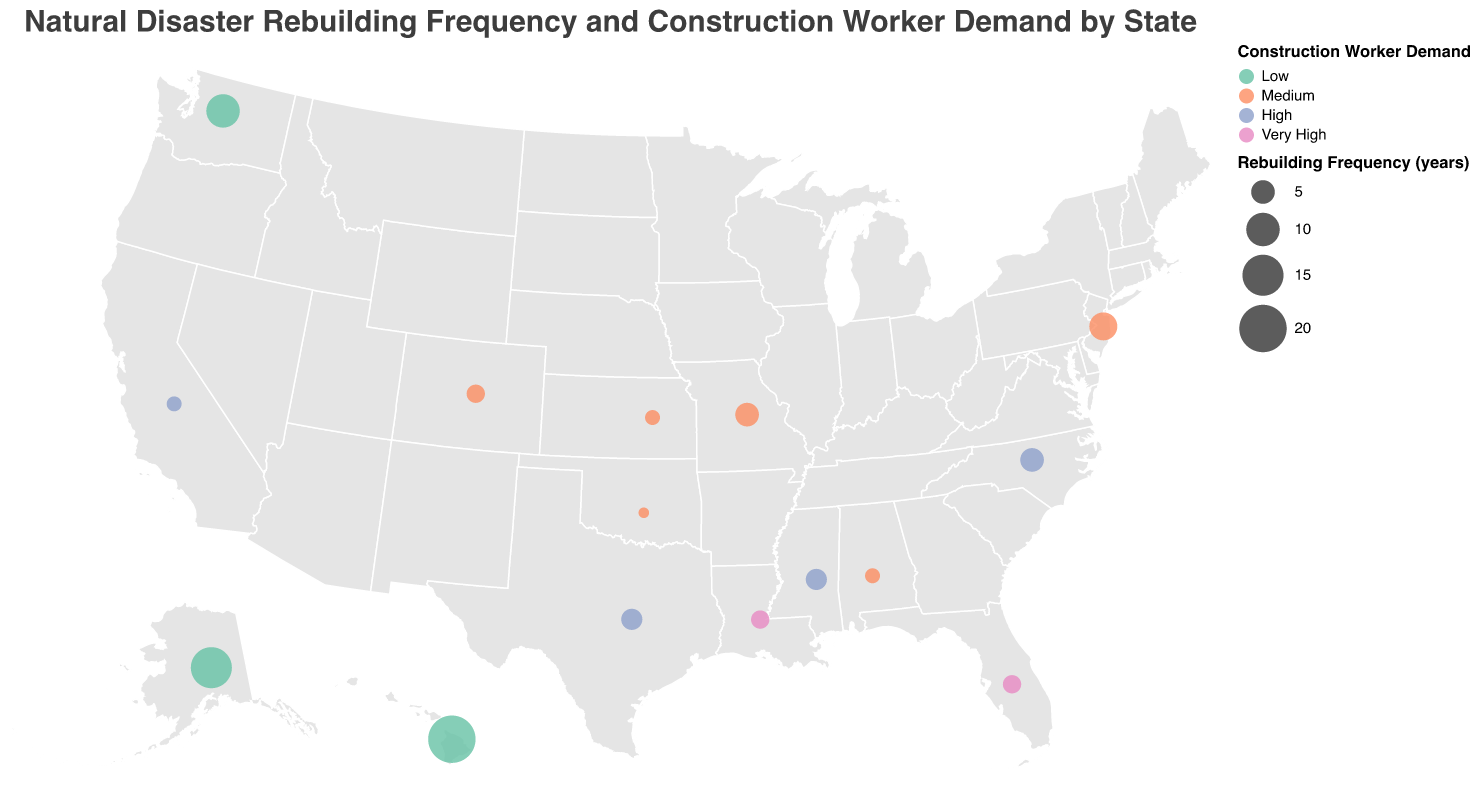What's the state with the shortest rebuilding frequency for natural disasters? By looking at the size of the circles, the state with the smallest circle (indicating the shortest rebuilding frequency) is Oklahoma with a frequency of 1 year.
Answer: Oklahoma Which states experience frequent hurricanes and have high construction worker demand? Look for states with hurricanes as the natural disaster type and check their construction worker demand color on the map. Florida, Louisiana, Texas, North Carolina, and Mississippi fit these criteria.
Answer: Florida, Louisiana, Texas, North Carolina, Mississippi What is the average rebuilding frequency for states facing tornadoes? First, identify states with tornadoes: Oklahoma, Kansas, and Alabama. Sum their rebuilding frequencies (1+2+2) = 5, then divide by the number of states (3). So, 5/3 ≈ 1.67 years.
Answer: 1.67 years Which state has the highest rebuilding frequency, and what is the natural disaster type? The state with the largest circle has the highest rebuilding frequency, which is Hawaii (20 years) with volcanic eruptions.
Answer: Hawaii, Volcanic Eruptions Compare the construction worker demand for states with earthquakes and state which one has the lower demand? States with earthquakes are Washington and Alaska. Both display 'Low' demand, indicating they have the same lower demand.
Answer: Washington, Alaska Based on the geographic plot, which state has medium construction worker demand but the longest rebuilding frequency? Look for medium demand states indicated in the chart and check their rebuilding frequencies. New Jersey has medium demand and a rebuilding frequency of 7 years, which is the longest among medium-demand states.
Answer: New Jersey Among states with wildfires, which one has a more frequent rebuilding rate? States with wildfires are California and Colorado. California has a rebuilding frequency of 2 years, while Colorado has 3 years. Therefore, California has a more frequent rebuilding rate.
Answer: California How does the rebuilding frequency of hurricanes in Florida compare to that in Louisiana? Both Florida and Louisiana have hurricanes as their natural disaster type. Florida's rebuilding frequency is 3 years, which is equal to Louisiana's 3 years.
Answer: Equal In which state would a construction worker be in highest demand due to hurricanes? Look for the states with 'Very High' construction worker demand and check if the natural disaster type is hurricanes. Florida and Louisiana both fit these criteria.
Answer: Florida, Louisiana 